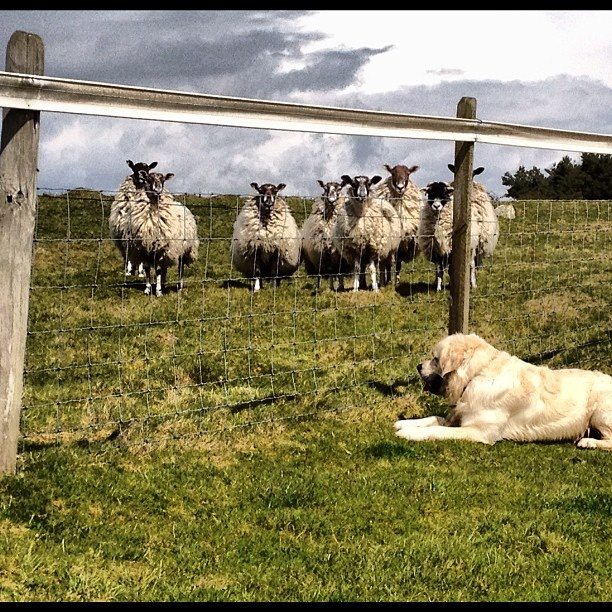Describe the objects in this image and their specific colors. I can see dog in black, tan, lightyellow, and olive tones, sheep in black, tan, and gray tones, sheep in black, tan, and gray tones, sheep in black, tan, and beige tones, and sheep in black and tan tones in this image. 